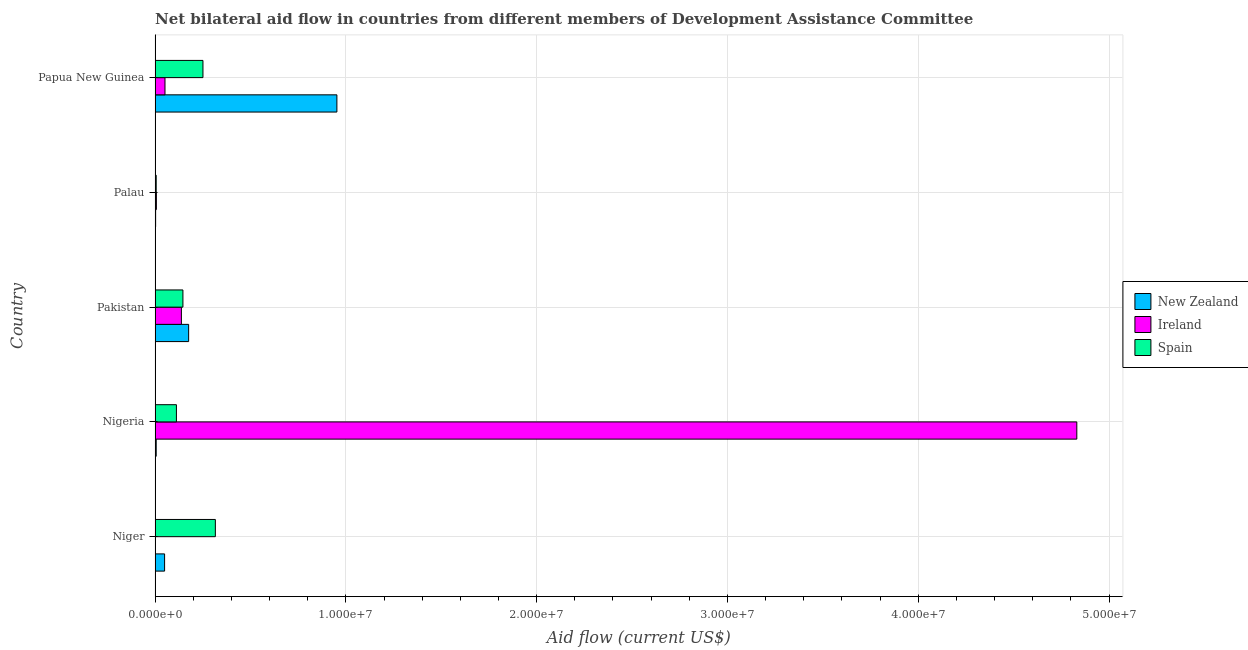How many groups of bars are there?
Keep it short and to the point. 5. Are the number of bars per tick equal to the number of legend labels?
Your answer should be very brief. Yes. Are the number of bars on each tick of the Y-axis equal?
Your response must be concise. Yes. How many bars are there on the 1st tick from the top?
Keep it short and to the point. 3. How many bars are there on the 4th tick from the bottom?
Offer a terse response. 3. What is the label of the 3rd group of bars from the top?
Give a very brief answer. Pakistan. What is the amount of aid provided by spain in Pakistan?
Your answer should be compact. 1.46e+06. Across all countries, what is the maximum amount of aid provided by ireland?
Make the answer very short. 4.83e+07. Across all countries, what is the minimum amount of aid provided by ireland?
Your answer should be compact. 2.00e+04. In which country was the amount of aid provided by ireland maximum?
Make the answer very short. Nigeria. In which country was the amount of aid provided by new zealand minimum?
Your answer should be very brief. Palau. What is the total amount of aid provided by spain in the graph?
Offer a terse response. 8.31e+06. What is the difference between the amount of aid provided by new zealand in Pakistan and that in Papua New Guinea?
Your answer should be compact. -7.77e+06. What is the difference between the amount of aid provided by ireland in Nigeria and the amount of aid provided by spain in Niger?
Give a very brief answer. 4.52e+07. What is the average amount of aid provided by ireland per country?
Provide a succinct answer. 1.01e+07. What is the difference between the amount of aid provided by ireland and amount of aid provided by new zealand in Niger?
Give a very brief answer. -4.80e+05. In how many countries, is the amount of aid provided by new zealand greater than 10000000 US$?
Make the answer very short. 0. What is the ratio of the amount of aid provided by new zealand in Pakistan to that in Palau?
Your answer should be compact. 58.67. What is the difference between the highest and the second highest amount of aid provided by spain?
Offer a terse response. 6.50e+05. What is the difference between the highest and the lowest amount of aid provided by ireland?
Keep it short and to the point. 4.83e+07. In how many countries, is the amount of aid provided by ireland greater than the average amount of aid provided by ireland taken over all countries?
Offer a terse response. 1. What does the 3rd bar from the top in Pakistan represents?
Make the answer very short. New Zealand. What does the 1st bar from the bottom in Papua New Guinea represents?
Provide a succinct answer. New Zealand. How many bars are there?
Make the answer very short. 15. Are all the bars in the graph horizontal?
Make the answer very short. Yes. How many countries are there in the graph?
Provide a short and direct response. 5. Are the values on the major ticks of X-axis written in scientific E-notation?
Your answer should be compact. Yes. What is the title of the graph?
Offer a terse response. Net bilateral aid flow in countries from different members of Development Assistance Committee. Does "Tertiary" appear as one of the legend labels in the graph?
Offer a terse response. No. What is the label or title of the X-axis?
Ensure brevity in your answer.  Aid flow (current US$). What is the label or title of the Y-axis?
Offer a terse response. Country. What is the Aid flow (current US$) in Spain in Niger?
Offer a terse response. 3.16e+06. What is the Aid flow (current US$) in Ireland in Nigeria?
Keep it short and to the point. 4.83e+07. What is the Aid flow (current US$) of Spain in Nigeria?
Your response must be concise. 1.12e+06. What is the Aid flow (current US$) of New Zealand in Pakistan?
Give a very brief answer. 1.76e+06. What is the Aid flow (current US$) in Ireland in Pakistan?
Make the answer very short. 1.38e+06. What is the Aid flow (current US$) of Spain in Pakistan?
Give a very brief answer. 1.46e+06. What is the Aid flow (current US$) of New Zealand in Palau?
Ensure brevity in your answer.  3.00e+04. What is the Aid flow (current US$) in Ireland in Palau?
Ensure brevity in your answer.  7.00e+04. What is the Aid flow (current US$) of New Zealand in Papua New Guinea?
Offer a very short reply. 9.53e+06. What is the Aid flow (current US$) of Ireland in Papua New Guinea?
Your response must be concise. 5.20e+05. What is the Aid flow (current US$) of Spain in Papua New Guinea?
Provide a short and direct response. 2.51e+06. Across all countries, what is the maximum Aid flow (current US$) in New Zealand?
Ensure brevity in your answer.  9.53e+06. Across all countries, what is the maximum Aid flow (current US$) in Ireland?
Provide a short and direct response. 4.83e+07. Across all countries, what is the maximum Aid flow (current US$) of Spain?
Provide a short and direct response. 3.16e+06. Across all countries, what is the minimum Aid flow (current US$) of Spain?
Offer a terse response. 6.00e+04. What is the total Aid flow (current US$) in New Zealand in the graph?
Keep it short and to the point. 1.19e+07. What is the total Aid flow (current US$) of Ireland in the graph?
Provide a short and direct response. 5.03e+07. What is the total Aid flow (current US$) in Spain in the graph?
Offer a terse response. 8.31e+06. What is the difference between the Aid flow (current US$) in Ireland in Niger and that in Nigeria?
Provide a succinct answer. -4.83e+07. What is the difference between the Aid flow (current US$) in Spain in Niger and that in Nigeria?
Give a very brief answer. 2.04e+06. What is the difference between the Aid flow (current US$) in New Zealand in Niger and that in Pakistan?
Your answer should be very brief. -1.26e+06. What is the difference between the Aid flow (current US$) of Ireland in Niger and that in Pakistan?
Ensure brevity in your answer.  -1.36e+06. What is the difference between the Aid flow (current US$) in Spain in Niger and that in Pakistan?
Make the answer very short. 1.70e+06. What is the difference between the Aid flow (current US$) of Ireland in Niger and that in Palau?
Provide a succinct answer. -5.00e+04. What is the difference between the Aid flow (current US$) in Spain in Niger and that in Palau?
Provide a succinct answer. 3.10e+06. What is the difference between the Aid flow (current US$) in New Zealand in Niger and that in Papua New Guinea?
Your response must be concise. -9.03e+06. What is the difference between the Aid flow (current US$) in Ireland in Niger and that in Papua New Guinea?
Your response must be concise. -5.00e+05. What is the difference between the Aid flow (current US$) of Spain in Niger and that in Papua New Guinea?
Keep it short and to the point. 6.50e+05. What is the difference between the Aid flow (current US$) of New Zealand in Nigeria and that in Pakistan?
Provide a succinct answer. -1.70e+06. What is the difference between the Aid flow (current US$) of Ireland in Nigeria and that in Pakistan?
Your answer should be compact. 4.69e+07. What is the difference between the Aid flow (current US$) in Spain in Nigeria and that in Pakistan?
Make the answer very short. -3.40e+05. What is the difference between the Aid flow (current US$) of Ireland in Nigeria and that in Palau?
Your answer should be very brief. 4.82e+07. What is the difference between the Aid flow (current US$) in Spain in Nigeria and that in Palau?
Ensure brevity in your answer.  1.06e+06. What is the difference between the Aid flow (current US$) of New Zealand in Nigeria and that in Papua New Guinea?
Ensure brevity in your answer.  -9.47e+06. What is the difference between the Aid flow (current US$) in Ireland in Nigeria and that in Papua New Guinea?
Make the answer very short. 4.78e+07. What is the difference between the Aid flow (current US$) of Spain in Nigeria and that in Papua New Guinea?
Offer a terse response. -1.39e+06. What is the difference between the Aid flow (current US$) in New Zealand in Pakistan and that in Palau?
Your answer should be very brief. 1.73e+06. What is the difference between the Aid flow (current US$) of Ireland in Pakistan and that in Palau?
Ensure brevity in your answer.  1.31e+06. What is the difference between the Aid flow (current US$) of Spain in Pakistan and that in Palau?
Ensure brevity in your answer.  1.40e+06. What is the difference between the Aid flow (current US$) of New Zealand in Pakistan and that in Papua New Guinea?
Offer a very short reply. -7.77e+06. What is the difference between the Aid flow (current US$) in Ireland in Pakistan and that in Papua New Guinea?
Your answer should be very brief. 8.60e+05. What is the difference between the Aid flow (current US$) of Spain in Pakistan and that in Papua New Guinea?
Give a very brief answer. -1.05e+06. What is the difference between the Aid flow (current US$) of New Zealand in Palau and that in Papua New Guinea?
Your response must be concise. -9.50e+06. What is the difference between the Aid flow (current US$) in Ireland in Palau and that in Papua New Guinea?
Provide a short and direct response. -4.50e+05. What is the difference between the Aid flow (current US$) of Spain in Palau and that in Papua New Guinea?
Provide a succinct answer. -2.45e+06. What is the difference between the Aid flow (current US$) in New Zealand in Niger and the Aid flow (current US$) in Ireland in Nigeria?
Keep it short and to the point. -4.78e+07. What is the difference between the Aid flow (current US$) of New Zealand in Niger and the Aid flow (current US$) of Spain in Nigeria?
Provide a short and direct response. -6.20e+05. What is the difference between the Aid flow (current US$) in Ireland in Niger and the Aid flow (current US$) in Spain in Nigeria?
Offer a very short reply. -1.10e+06. What is the difference between the Aid flow (current US$) in New Zealand in Niger and the Aid flow (current US$) in Ireland in Pakistan?
Make the answer very short. -8.80e+05. What is the difference between the Aid flow (current US$) in New Zealand in Niger and the Aid flow (current US$) in Spain in Pakistan?
Your answer should be compact. -9.60e+05. What is the difference between the Aid flow (current US$) of Ireland in Niger and the Aid flow (current US$) of Spain in Pakistan?
Offer a very short reply. -1.44e+06. What is the difference between the Aid flow (current US$) in New Zealand in Niger and the Aid flow (current US$) in Ireland in Palau?
Your answer should be compact. 4.30e+05. What is the difference between the Aid flow (current US$) of Ireland in Niger and the Aid flow (current US$) of Spain in Palau?
Give a very brief answer. -4.00e+04. What is the difference between the Aid flow (current US$) of New Zealand in Niger and the Aid flow (current US$) of Ireland in Papua New Guinea?
Make the answer very short. -2.00e+04. What is the difference between the Aid flow (current US$) in New Zealand in Niger and the Aid flow (current US$) in Spain in Papua New Guinea?
Provide a short and direct response. -2.01e+06. What is the difference between the Aid flow (current US$) in Ireland in Niger and the Aid flow (current US$) in Spain in Papua New Guinea?
Your answer should be very brief. -2.49e+06. What is the difference between the Aid flow (current US$) of New Zealand in Nigeria and the Aid flow (current US$) of Ireland in Pakistan?
Provide a succinct answer. -1.32e+06. What is the difference between the Aid flow (current US$) in New Zealand in Nigeria and the Aid flow (current US$) in Spain in Pakistan?
Your answer should be compact. -1.40e+06. What is the difference between the Aid flow (current US$) in Ireland in Nigeria and the Aid flow (current US$) in Spain in Pakistan?
Offer a very short reply. 4.68e+07. What is the difference between the Aid flow (current US$) in Ireland in Nigeria and the Aid flow (current US$) in Spain in Palau?
Provide a short and direct response. 4.82e+07. What is the difference between the Aid flow (current US$) in New Zealand in Nigeria and the Aid flow (current US$) in Ireland in Papua New Guinea?
Ensure brevity in your answer.  -4.60e+05. What is the difference between the Aid flow (current US$) in New Zealand in Nigeria and the Aid flow (current US$) in Spain in Papua New Guinea?
Provide a succinct answer. -2.45e+06. What is the difference between the Aid flow (current US$) in Ireland in Nigeria and the Aid flow (current US$) in Spain in Papua New Guinea?
Make the answer very short. 4.58e+07. What is the difference between the Aid flow (current US$) of New Zealand in Pakistan and the Aid flow (current US$) of Ireland in Palau?
Offer a terse response. 1.69e+06. What is the difference between the Aid flow (current US$) in New Zealand in Pakistan and the Aid flow (current US$) in Spain in Palau?
Keep it short and to the point. 1.70e+06. What is the difference between the Aid flow (current US$) of Ireland in Pakistan and the Aid flow (current US$) of Spain in Palau?
Keep it short and to the point. 1.32e+06. What is the difference between the Aid flow (current US$) of New Zealand in Pakistan and the Aid flow (current US$) of Ireland in Papua New Guinea?
Your response must be concise. 1.24e+06. What is the difference between the Aid flow (current US$) in New Zealand in Pakistan and the Aid flow (current US$) in Spain in Papua New Guinea?
Your answer should be very brief. -7.50e+05. What is the difference between the Aid flow (current US$) of Ireland in Pakistan and the Aid flow (current US$) of Spain in Papua New Guinea?
Ensure brevity in your answer.  -1.13e+06. What is the difference between the Aid flow (current US$) of New Zealand in Palau and the Aid flow (current US$) of Ireland in Papua New Guinea?
Provide a short and direct response. -4.90e+05. What is the difference between the Aid flow (current US$) in New Zealand in Palau and the Aid flow (current US$) in Spain in Papua New Guinea?
Your response must be concise. -2.48e+06. What is the difference between the Aid flow (current US$) in Ireland in Palau and the Aid flow (current US$) in Spain in Papua New Guinea?
Provide a succinct answer. -2.44e+06. What is the average Aid flow (current US$) in New Zealand per country?
Your answer should be very brief. 2.38e+06. What is the average Aid flow (current US$) in Ireland per country?
Your response must be concise. 1.01e+07. What is the average Aid flow (current US$) in Spain per country?
Offer a terse response. 1.66e+06. What is the difference between the Aid flow (current US$) in New Zealand and Aid flow (current US$) in Spain in Niger?
Keep it short and to the point. -2.66e+06. What is the difference between the Aid flow (current US$) in Ireland and Aid flow (current US$) in Spain in Niger?
Give a very brief answer. -3.14e+06. What is the difference between the Aid flow (current US$) of New Zealand and Aid flow (current US$) of Ireland in Nigeria?
Your response must be concise. -4.82e+07. What is the difference between the Aid flow (current US$) in New Zealand and Aid flow (current US$) in Spain in Nigeria?
Your answer should be very brief. -1.06e+06. What is the difference between the Aid flow (current US$) of Ireland and Aid flow (current US$) of Spain in Nigeria?
Your answer should be compact. 4.72e+07. What is the difference between the Aid flow (current US$) of New Zealand and Aid flow (current US$) of Spain in Pakistan?
Your response must be concise. 3.00e+05. What is the difference between the Aid flow (current US$) in Ireland and Aid flow (current US$) in Spain in Pakistan?
Your answer should be very brief. -8.00e+04. What is the difference between the Aid flow (current US$) of New Zealand and Aid flow (current US$) of Ireland in Palau?
Make the answer very short. -4.00e+04. What is the difference between the Aid flow (current US$) of Ireland and Aid flow (current US$) of Spain in Palau?
Make the answer very short. 10000. What is the difference between the Aid flow (current US$) in New Zealand and Aid flow (current US$) in Ireland in Papua New Guinea?
Your answer should be very brief. 9.01e+06. What is the difference between the Aid flow (current US$) of New Zealand and Aid flow (current US$) of Spain in Papua New Guinea?
Your answer should be compact. 7.02e+06. What is the difference between the Aid flow (current US$) of Ireland and Aid flow (current US$) of Spain in Papua New Guinea?
Give a very brief answer. -1.99e+06. What is the ratio of the Aid flow (current US$) in New Zealand in Niger to that in Nigeria?
Give a very brief answer. 8.33. What is the ratio of the Aid flow (current US$) of Ireland in Niger to that in Nigeria?
Ensure brevity in your answer.  0. What is the ratio of the Aid flow (current US$) of Spain in Niger to that in Nigeria?
Your response must be concise. 2.82. What is the ratio of the Aid flow (current US$) in New Zealand in Niger to that in Pakistan?
Your answer should be compact. 0.28. What is the ratio of the Aid flow (current US$) in Ireland in Niger to that in Pakistan?
Your answer should be very brief. 0.01. What is the ratio of the Aid flow (current US$) in Spain in Niger to that in Pakistan?
Your answer should be very brief. 2.16. What is the ratio of the Aid flow (current US$) in New Zealand in Niger to that in Palau?
Ensure brevity in your answer.  16.67. What is the ratio of the Aid flow (current US$) in Ireland in Niger to that in Palau?
Offer a very short reply. 0.29. What is the ratio of the Aid flow (current US$) in Spain in Niger to that in Palau?
Provide a succinct answer. 52.67. What is the ratio of the Aid flow (current US$) of New Zealand in Niger to that in Papua New Guinea?
Ensure brevity in your answer.  0.05. What is the ratio of the Aid flow (current US$) in Ireland in Niger to that in Papua New Guinea?
Keep it short and to the point. 0.04. What is the ratio of the Aid flow (current US$) in Spain in Niger to that in Papua New Guinea?
Offer a very short reply. 1.26. What is the ratio of the Aid flow (current US$) in New Zealand in Nigeria to that in Pakistan?
Provide a short and direct response. 0.03. What is the ratio of the Aid flow (current US$) of Ireland in Nigeria to that in Pakistan?
Your answer should be compact. 35.01. What is the ratio of the Aid flow (current US$) in Spain in Nigeria to that in Pakistan?
Your answer should be very brief. 0.77. What is the ratio of the Aid flow (current US$) in New Zealand in Nigeria to that in Palau?
Your response must be concise. 2. What is the ratio of the Aid flow (current US$) of Ireland in Nigeria to that in Palau?
Make the answer very short. 690.14. What is the ratio of the Aid flow (current US$) in Spain in Nigeria to that in Palau?
Keep it short and to the point. 18.67. What is the ratio of the Aid flow (current US$) of New Zealand in Nigeria to that in Papua New Guinea?
Offer a terse response. 0.01. What is the ratio of the Aid flow (current US$) of Ireland in Nigeria to that in Papua New Guinea?
Ensure brevity in your answer.  92.9. What is the ratio of the Aid flow (current US$) in Spain in Nigeria to that in Papua New Guinea?
Provide a short and direct response. 0.45. What is the ratio of the Aid flow (current US$) in New Zealand in Pakistan to that in Palau?
Offer a very short reply. 58.67. What is the ratio of the Aid flow (current US$) of Ireland in Pakistan to that in Palau?
Your answer should be compact. 19.71. What is the ratio of the Aid flow (current US$) in Spain in Pakistan to that in Palau?
Provide a succinct answer. 24.33. What is the ratio of the Aid flow (current US$) in New Zealand in Pakistan to that in Papua New Guinea?
Your answer should be compact. 0.18. What is the ratio of the Aid flow (current US$) of Ireland in Pakistan to that in Papua New Guinea?
Provide a short and direct response. 2.65. What is the ratio of the Aid flow (current US$) in Spain in Pakistan to that in Papua New Guinea?
Offer a terse response. 0.58. What is the ratio of the Aid flow (current US$) of New Zealand in Palau to that in Papua New Guinea?
Give a very brief answer. 0. What is the ratio of the Aid flow (current US$) of Ireland in Palau to that in Papua New Guinea?
Offer a terse response. 0.13. What is the ratio of the Aid flow (current US$) of Spain in Palau to that in Papua New Guinea?
Provide a succinct answer. 0.02. What is the difference between the highest and the second highest Aid flow (current US$) in New Zealand?
Provide a short and direct response. 7.77e+06. What is the difference between the highest and the second highest Aid flow (current US$) of Ireland?
Your response must be concise. 4.69e+07. What is the difference between the highest and the second highest Aid flow (current US$) in Spain?
Your response must be concise. 6.50e+05. What is the difference between the highest and the lowest Aid flow (current US$) of New Zealand?
Keep it short and to the point. 9.50e+06. What is the difference between the highest and the lowest Aid flow (current US$) in Ireland?
Your response must be concise. 4.83e+07. What is the difference between the highest and the lowest Aid flow (current US$) of Spain?
Make the answer very short. 3.10e+06. 